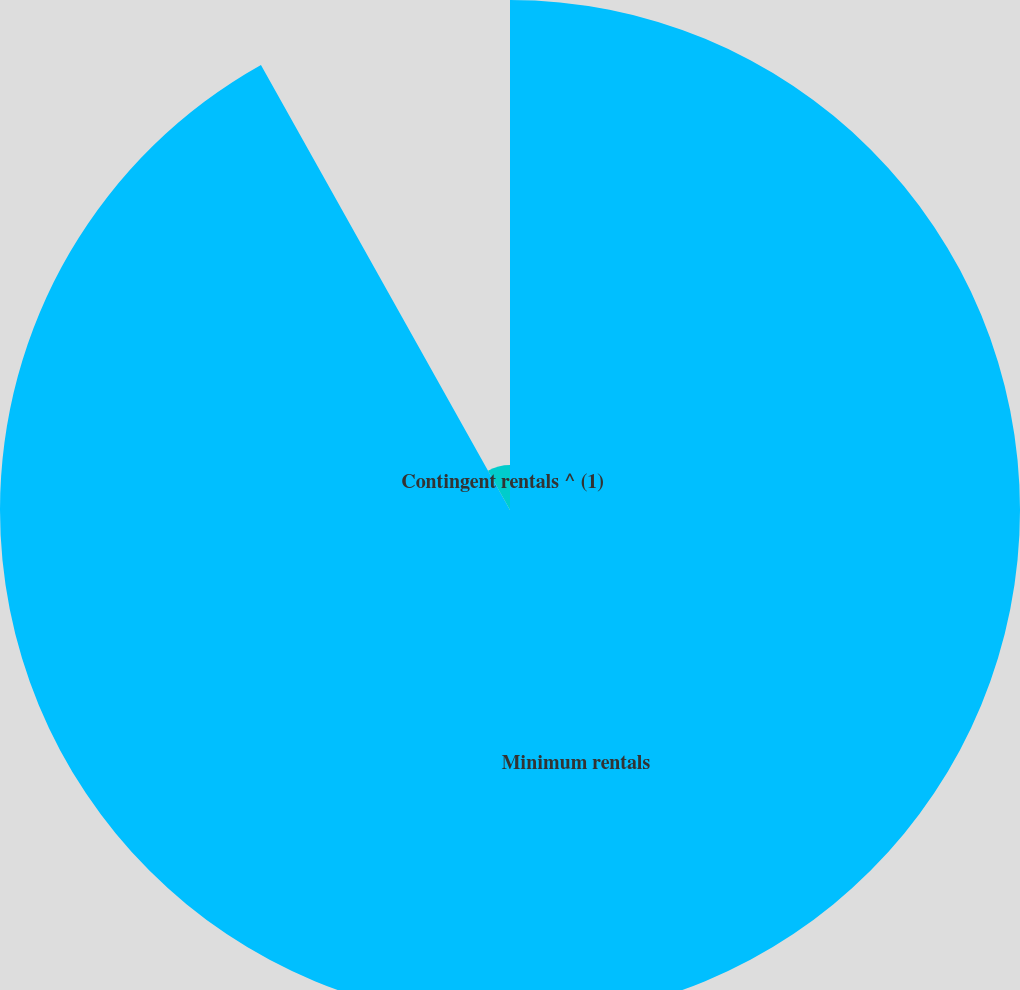Convert chart to OTSL. <chart><loc_0><loc_0><loc_500><loc_500><pie_chart><fcel>Minimum rentals<fcel>Contingent rentals ^ (1)<nl><fcel>91.88%<fcel>8.12%<nl></chart> 